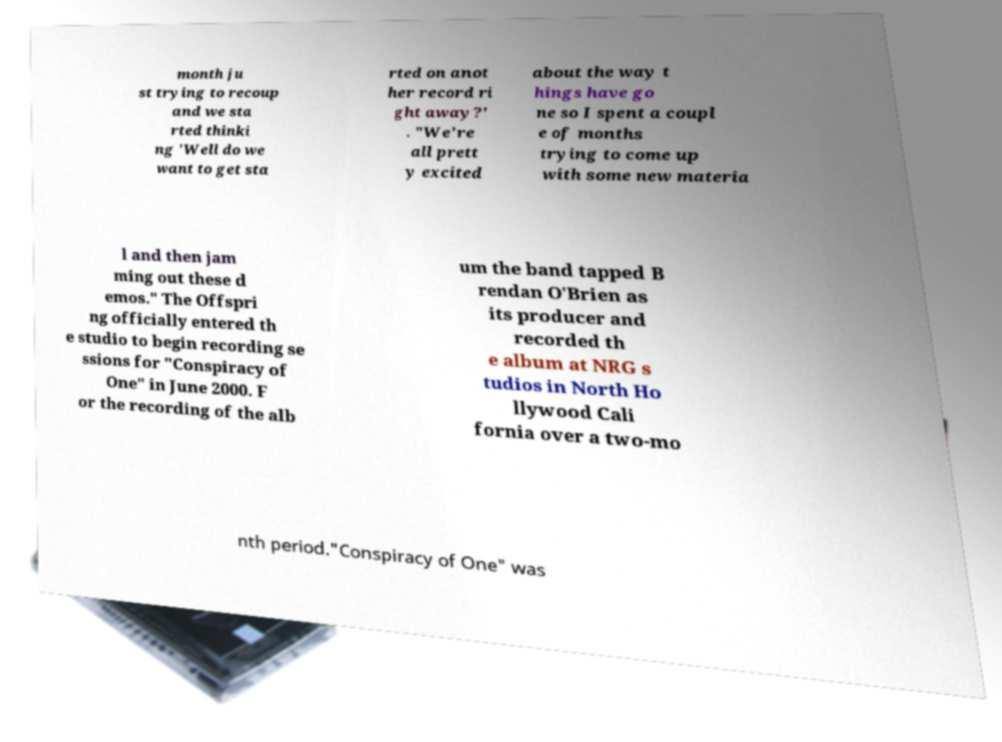Can you read and provide the text displayed in the image?This photo seems to have some interesting text. Can you extract and type it out for me? month ju st trying to recoup and we sta rted thinki ng 'Well do we want to get sta rted on anot her record ri ght away?' . "We're all prett y excited about the way t hings have go ne so I spent a coupl e of months trying to come up with some new materia l and then jam ming out these d emos." The Offspri ng officially entered th e studio to begin recording se ssions for "Conspiracy of One" in June 2000. F or the recording of the alb um the band tapped B rendan O'Brien as its producer and recorded th e album at NRG s tudios in North Ho llywood Cali fornia over a two-mo nth period."Conspiracy of One" was 